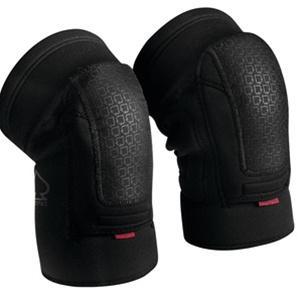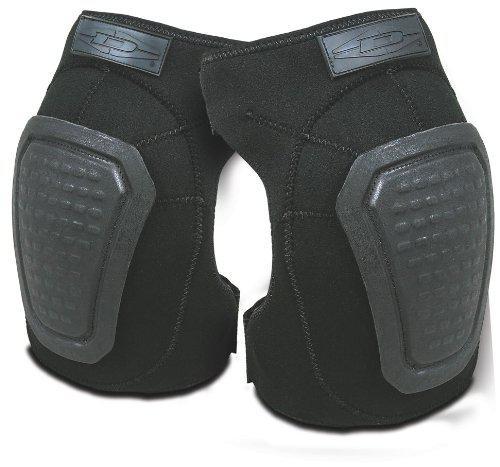The first image is the image on the left, the second image is the image on the right. Examine the images to the left and right. Is the description "The knee pads in the image on the right have no white markings." accurate? Answer yes or no. Yes. The first image is the image on the left, the second image is the image on the right. Given the left and right images, does the statement "An image shows a pair of unworn, smooth black kneepads with no texture turned rightward." hold true? Answer yes or no. No. 